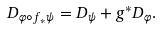<formula> <loc_0><loc_0><loc_500><loc_500>D _ { \varphi \circ f _ { * } \psi } = D _ { \psi } + g ^ { * } D _ { \varphi } .</formula> 